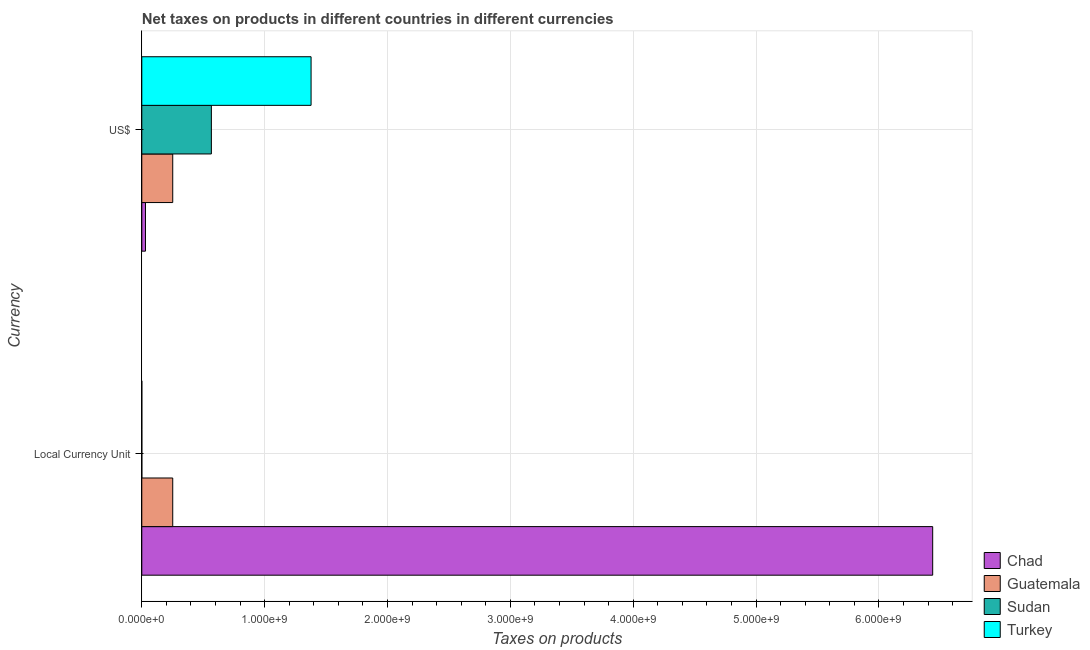How many bars are there on the 2nd tick from the top?
Make the answer very short. 4. How many bars are there on the 2nd tick from the bottom?
Your answer should be compact. 4. What is the label of the 2nd group of bars from the top?
Make the answer very short. Local Currency Unit. What is the net taxes in constant 2005 us$ in Chad?
Offer a very short reply. 6.44e+09. Across all countries, what is the maximum net taxes in us$?
Offer a very short reply. 1.38e+09. Across all countries, what is the minimum net taxes in constant 2005 us$?
Offer a very short reply. 1.99e+04. In which country was the net taxes in constant 2005 us$ maximum?
Your answer should be very brief. Chad. In which country was the net taxes in constant 2005 us$ minimum?
Your response must be concise. Turkey. What is the total net taxes in us$ in the graph?
Provide a short and direct response. 2.23e+09. What is the difference between the net taxes in us$ in Chad and that in Turkey?
Offer a very short reply. -1.35e+09. What is the difference between the net taxes in constant 2005 us$ in Turkey and the net taxes in us$ in Sudan?
Give a very brief answer. -5.66e+08. What is the average net taxes in us$ per country?
Make the answer very short. 5.57e+08. What is the difference between the net taxes in us$ and net taxes in constant 2005 us$ in Guatemala?
Your answer should be compact. 0. What is the ratio of the net taxes in us$ in Turkey to that in Sudan?
Your response must be concise. 2.43. In how many countries, is the net taxes in us$ greater than the average net taxes in us$ taken over all countries?
Ensure brevity in your answer.  2. What does the 1st bar from the top in US$ represents?
Keep it short and to the point. Turkey. What does the 3rd bar from the bottom in Local Currency Unit represents?
Ensure brevity in your answer.  Sudan. Where does the legend appear in the graph?
Provide a short and direct response. Bottom right. How many legend labels are there?
Ensure brevity in your answer.  4. How are the legend labels stacked?
Your answer should be compact. Vertical. What is the title of the graph?
Ensure brevity in your answer.  Net taxes on products in different countries in different currencies. Does "Solomon Islands" appear as one of the legend labels in the graph?
Your answer should be very brief. No. What is the label or title of the X-axis?
Give a very brief answer. Taxes on products. What is the label or title of the Y-axis?
Offer a terse response. Currency. What is the Taxes on products in Chad in Local Currency Unit?
Make the answer very short. 6.44e+09. What is the Taxes on products in Guatemala in Local Currency Unit?
Ensure brevity in your answer.  2.52e+08. What is the Taxes on products of Sudan in Local Currency Unit?
Ensure brevity in your answer.  1.97e+05. What is the Taxes on products in Turkey in Local Currency Unit?
Offer a very short reply. 1.99e+04. What is the Taxes on products of Chad in US$?
Offer a very short reply. 3.00e+07. What is the Taxes on products of Guatemala in US$?
Provide a short and direct response. 2.52e+08. What is the Taxes on products of Sudan in US$?
Offer a terse response. 5.66e+08. What is the Taxes on products in Turkey in US$?
Give a very brief answer. 1.38e+09. Across all Currency, what is the maximum Taxes on products of Chad?
Your answer should be very brief. 6.44e+09. Across all Currency, what is the maximum Taxes on products in Guatemala?
Your answer should be compact. 2.52e+08. Across all Currency, what is the maximum Taxes on products of Sudan?
Provide a short and direct response. 5.66e+08. Across all Currency, what is the maximum Taxes on products in Turkey?
Provide a short and direct response. 1.38e+09. Across all Currency, what is the minimum Taxes on products of Chad?
Your answer should be compact. 3.00e+07. Across all Currency, what is the minimum Taxes on products of Guatemala?
Provide a succinct answer. 2.52e+08. Across all Currency, what is the minimum Taxes on products of Sudan?
Keep it short and to the point. 1.97e+05. Across all Currency, what is the minimum Taxes on products in Turkey?
Provide a succinct answer. 1.99e+04. What is the total Taxes on products in Chad in the graph?
Keep it short and to the point. 6.47e+09. What is the total Taxes on products of Guatemala in the graph?
Ensure brevity in your answer.  5.04e+08. What is the total Taxes on products in Sudan in the graph?
Provide a short and direct response. 5.67e+08. What is the total Taxes on products of Turkey in the graph?
Make the answer very short. 1.38e+09. What is the difference between the Taxes on products in Chad in Local Currency Unit and that in US$?
Give a very brief answer. 6.41e+09. What is the difference between the Taxes on products of Sudan in Local Currency Unit and that in US$?
Give a very brief answer. -5.66e+08. What is the difference between the Taxes on products in Turkey in Local Currency Unit and that in US$?
Offer a terse response. -1.38e+09. What is the difference between the Taxes on products of Chad in Local Currency Unit and the Taxes on products of Guatemala in US$?
Offer a terse response. 6.19e+09. What is the difference between the Taxes on products in Chad in Local Currency Unit and the Taxes on products in Sudan in US$?
Your response must be concise. 5.87e+09. What is the difference between the Taxes on products in Chad in Local Currency Unit and the Taxes on products in Turkey in US$?
Your answer should be very brief. 5.06e+09. What is the difference between the Taxes on products in Guatemala in Local Currency Unit and the Taxes on products in Sudan in US$?
Your answer should be very brief. -3.15e+08. What is the difference between the Taxes on products of Guatemala in Local Currency Unit and the Taxes on products of Turkey in US$?
Provide a short and direct response. -1.13e+09. What is the difference between the Taxes on products in Sudan in Local Currency Unit and the Taxes on products in Turkey in US$?
Keep it short and to the point. -1.38e+09. What is the average Taxes on products of Chad per Currency?
Your answer should be very brief. 3.23e+09. What is the average Taxes on products in Guatemala per Currency?
Give a very brief answer. 2.52e+08. What is the average Taxes on products of Sudan per Currency?
Make the answer very short. 2.83e+08. What is the average Taxes on products in Turkey per Currency?
Keep it short and to the point. 6.89e+08. What is the difference between the Taxes on products in Chad and Taxes on products in Guatemala in Local Currency Unit?
Offer a terse response. 6.19e+09. What is the difference between the Taxes on products of Chad and Taxes on products of Sudan in Local Currency Unit?
Give a very brief answer. 6.44e+09. What is the difference between the Taxes on products of Chad and Taxes on products of Turkey in Local Currency Unit?
Provide a short and direct response. 6.44e+09. What is the difference between the Taxes on products of Guatemala and Taxes on products of Sudan in Local Currency Unit?
Offer a terse response. 2.52e+08. What is the difference between the Taxes on products of Guatemala and Taxes on products of Turkey in Local Currency Unit?
Keep it short and to the point. 2.52e+08. What is the difference between the Taxes on products of Sudan and Taxes on products of Turkey in Local Currency Unit?
Make the answer very short. 1.77e+05. What is the difference between the Taxes on products in Chad and Taxes on products in Guatemala in US$?
Make the answer very short. -2.22e+08. What is the difference between the Taxes on products of Chad and Taxes on products of Sudan in US$?
Give a very brief answer. -5.36e+08. What is the difference between the Taxes on products in Chad and Taxes on products in Turkey in US$?
Give a very brief answer. -1.35e+09. What is the difference between the Taxes on products of Guatemala and Taxes on products of Sudan in US$?
Offer a very short reply. -3.15e+08. What is the difference between the Taxes on products of Guatemala and Taxes on products of Turkey in US$?
Provide a short and direct response. -1.13e+09. What is the difference between the Taxes on products of Sudan and Taxes on products of Turkey in US$?
Make the answer very short. -8.12e+08. What is the ratio of the Taxes on products of Chad in Local Currency Unit to that in US$?
Make the answer very short. 214.31. What is the ratio of the Taxes on products in Guatemala in Local Currency Unit to that in US$?
Offer a very short reply. 1. What is the ratio of the Taxes on products in Turkey in Local Currency Unit to that in US$?
Your answer should be compact. 0. What is the difference between the highest and the second highest Taxes on products in Chad?
Make the answer very short. 6.41e+09. What is the difference between the highest and the second highest Taxes on products of Guatemala?
Keep it short and to the point. 0. What is the difference between the highest and the second highest Taxes on products of Sudan?
Provide a succinct answer. 5.66e+08. What is the difference between the highest and the second highest Taxes on products of Turkey?
Offer a very short reply. 1.38e+09. What is the difference between the highest and the lowest Taxes on products of Chad?
Your response must be concise. 6.41e+09. What is the difference between the highest and the lowest Taxes on products in Guatemala?
Provide a succinct answer. 0. What is the difference between the highest and the lowest Taxes on products of Sudan?
Make the answer very short. 5.66e+08. What is the difference between the highest and the lowest Taxes on products in Turkey?
Your answer should be compact. 1.38e+09. 